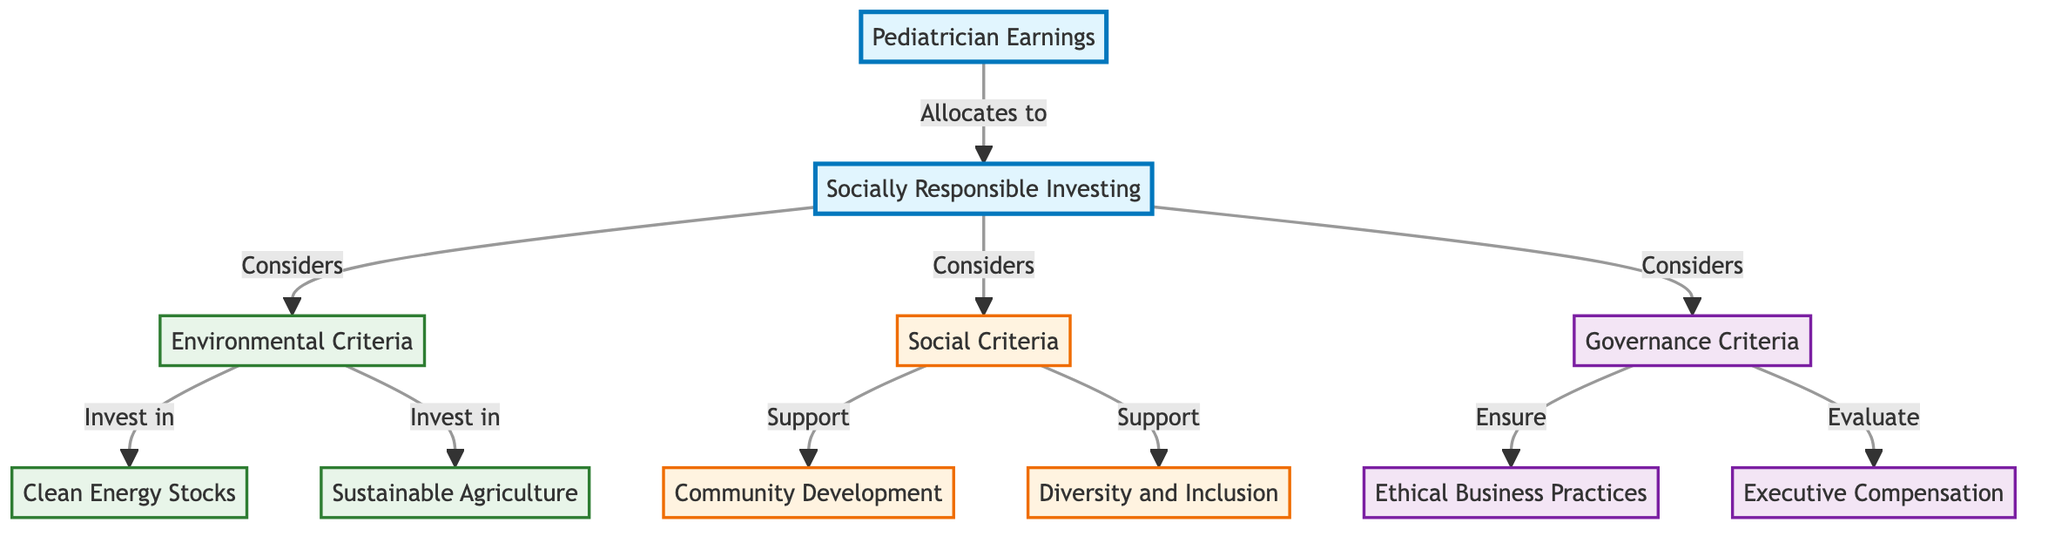What is the first node of the diagram? The first node in the diagram is "Pediatrician Earnings." It is visually positioned at the top and indicates the starting point of investment allocation.
Answer: Pediatrician Earnings How many criteria are considered in socially responsible investing? There are three criteria shown in the diagram: Environmental Criteria, Social Criteria, and Governance Criteria. Each criterion is represented as a separate node branching out from the main investing node.
Answer: 3 Which node represents Clean Energy Stocks? The node "Clean Energy Stocks" directly stems from the "Environmental Criteria" node and signifies a specific investment area focused on energy sustainability.
Answer: Clean Energy Stocks What do the Social Criteria support? The "Social Criteria" supports two nodes: "Community Development" and "Diversity and Inclusion," which illustrate the social aspects of investing priorities aimed at community impact and workplace diversification.
Answer: Community Development and Diversity and Inclusion How does the "Governance Criteria" ensure ethical practices? The "Governance Criteria" ensures ethical business practices through two nodes: "Ethical Business Practices" and "Executive Compensation," showing mechanisms to evaluate and uphold governance standards.
Answer: Ethical Business Practices and Executive Compensation Which node is a part of the "Environmental Criteria"? The node "Sustainable Agriculture" is part of the "Environmental Criteria," indicating an investment focus that promotes agricultural practices in an environmentally friendly manner.
Answer: Sustainable Agriculture What does the "Pediatrician Earnings" allocate to? "Pediatrician Earnings" allocates to "Socially Responsible Investing," which serves as the central hub of the diagram, depicting the overall investment strategy.
Answer: Socially Responsible Investing Which color represents the Governance Criteria in the diagram? The "Governance Criteria" is represented in purple, which visually differentiates it from the other criteria and emphasizes its distinct category.
Answer: Purple 